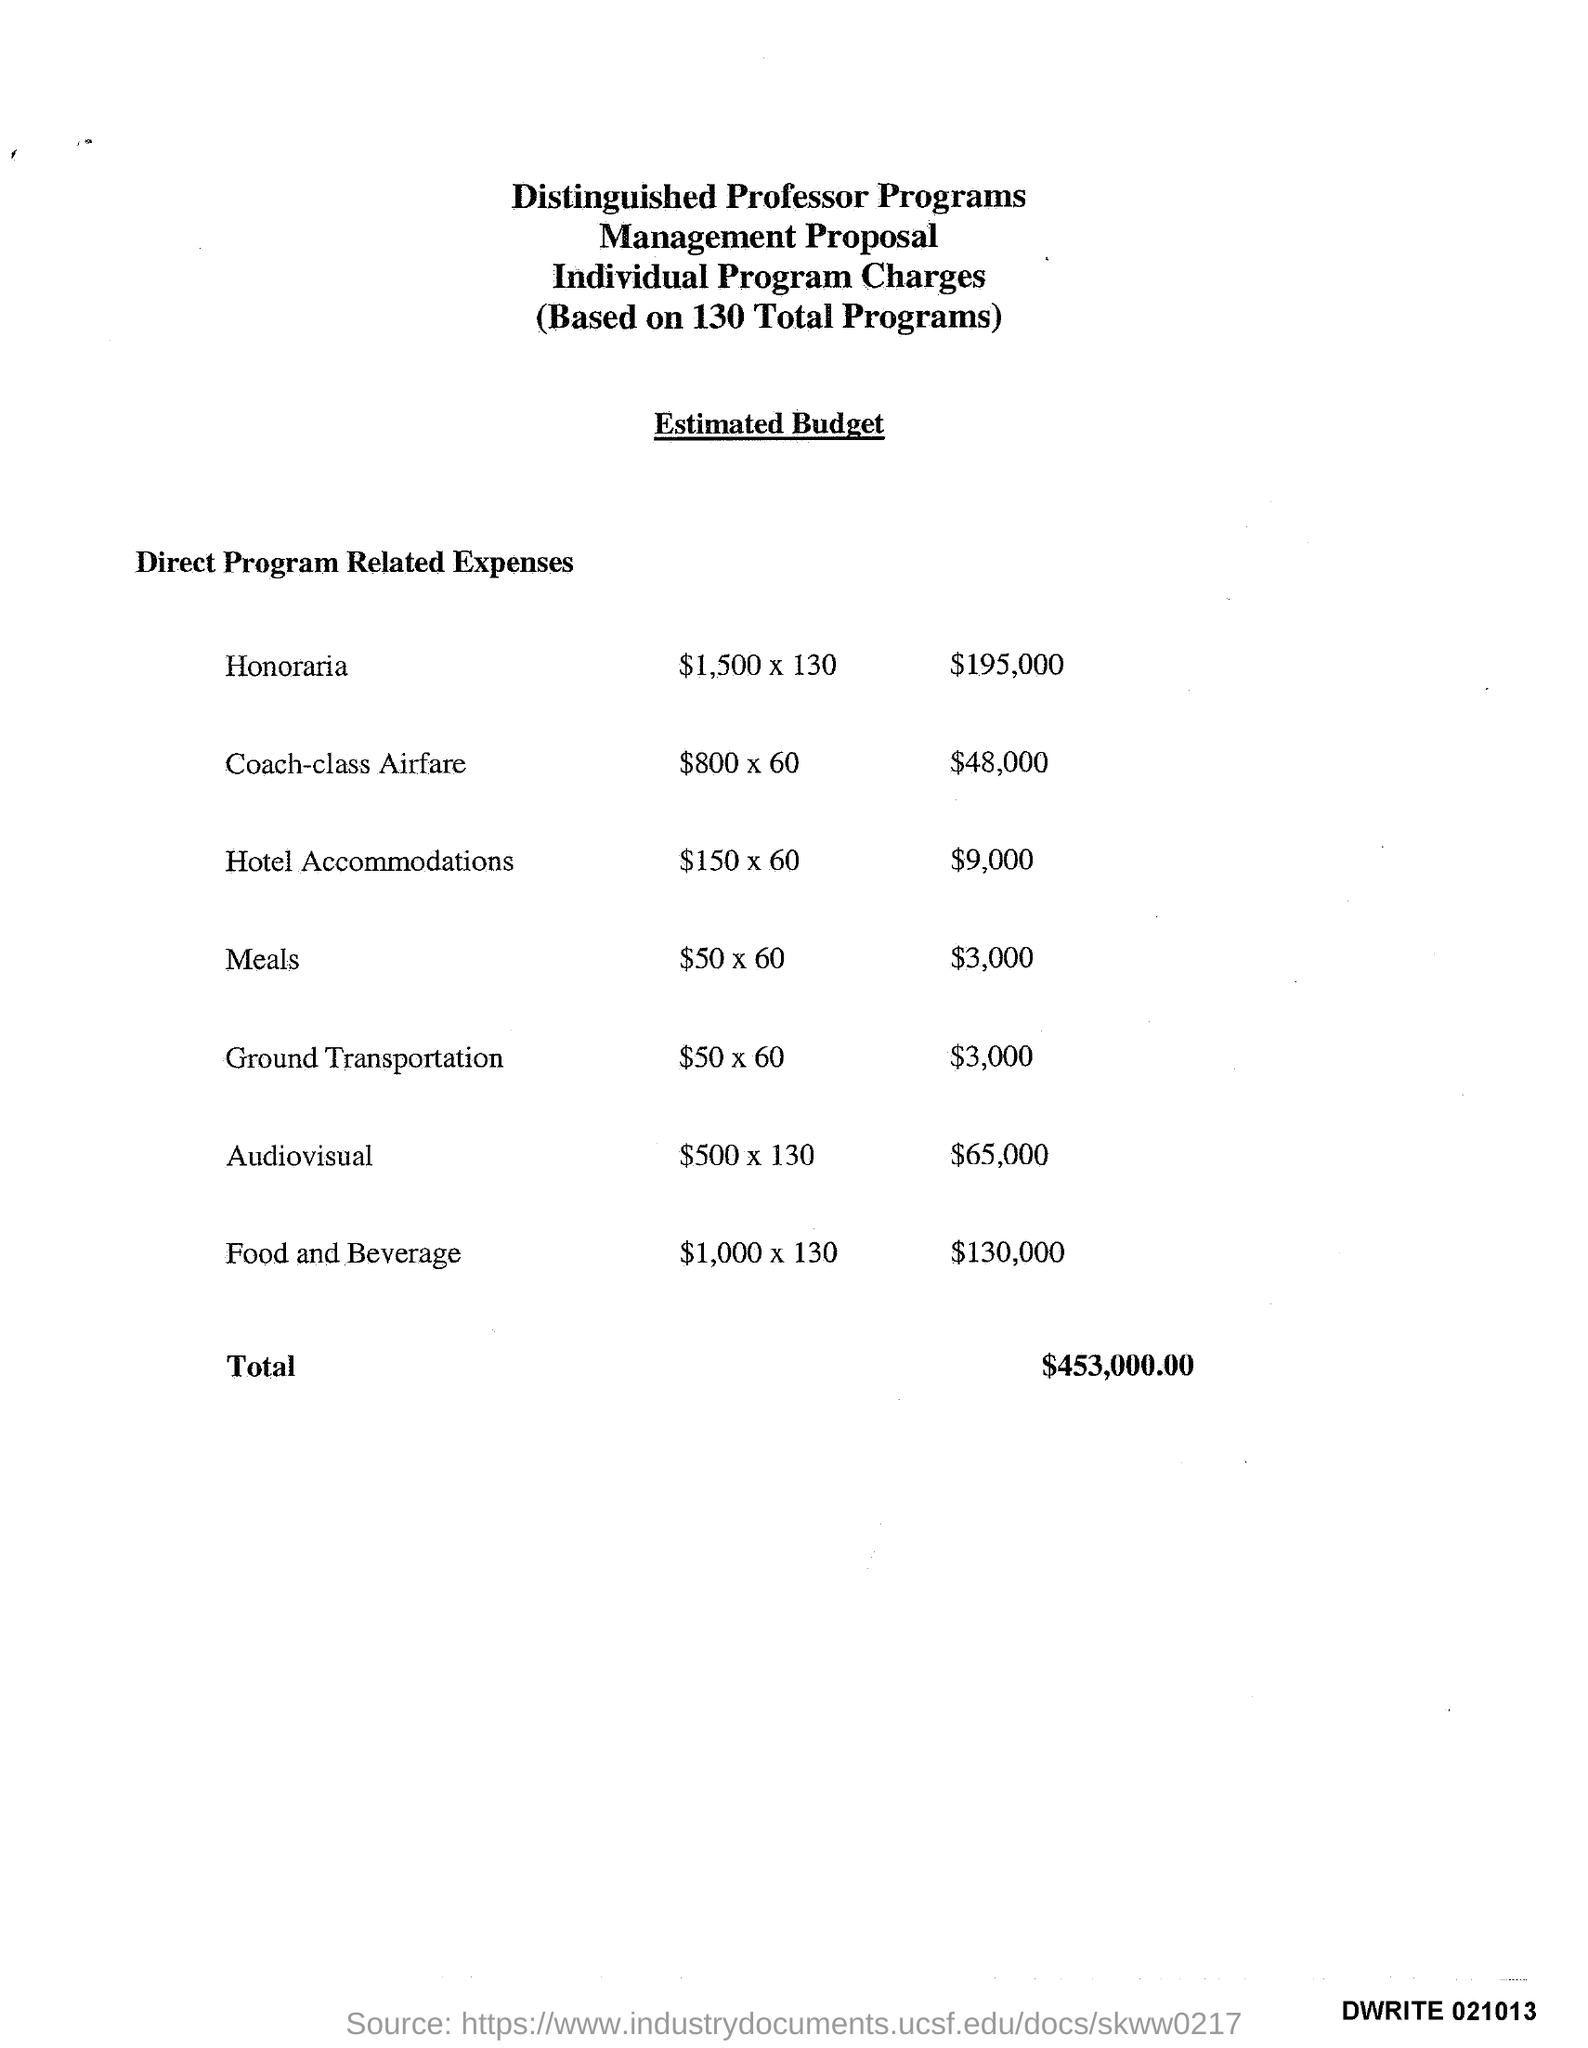what is the name of the program which spent $195,000? The program that allocated $195,000 is for 'Honoraria'. This expense is for payments made to individuals for their professional services within the Distinguished Professor Programs. The total amount covers honoraria for 130 programs. 